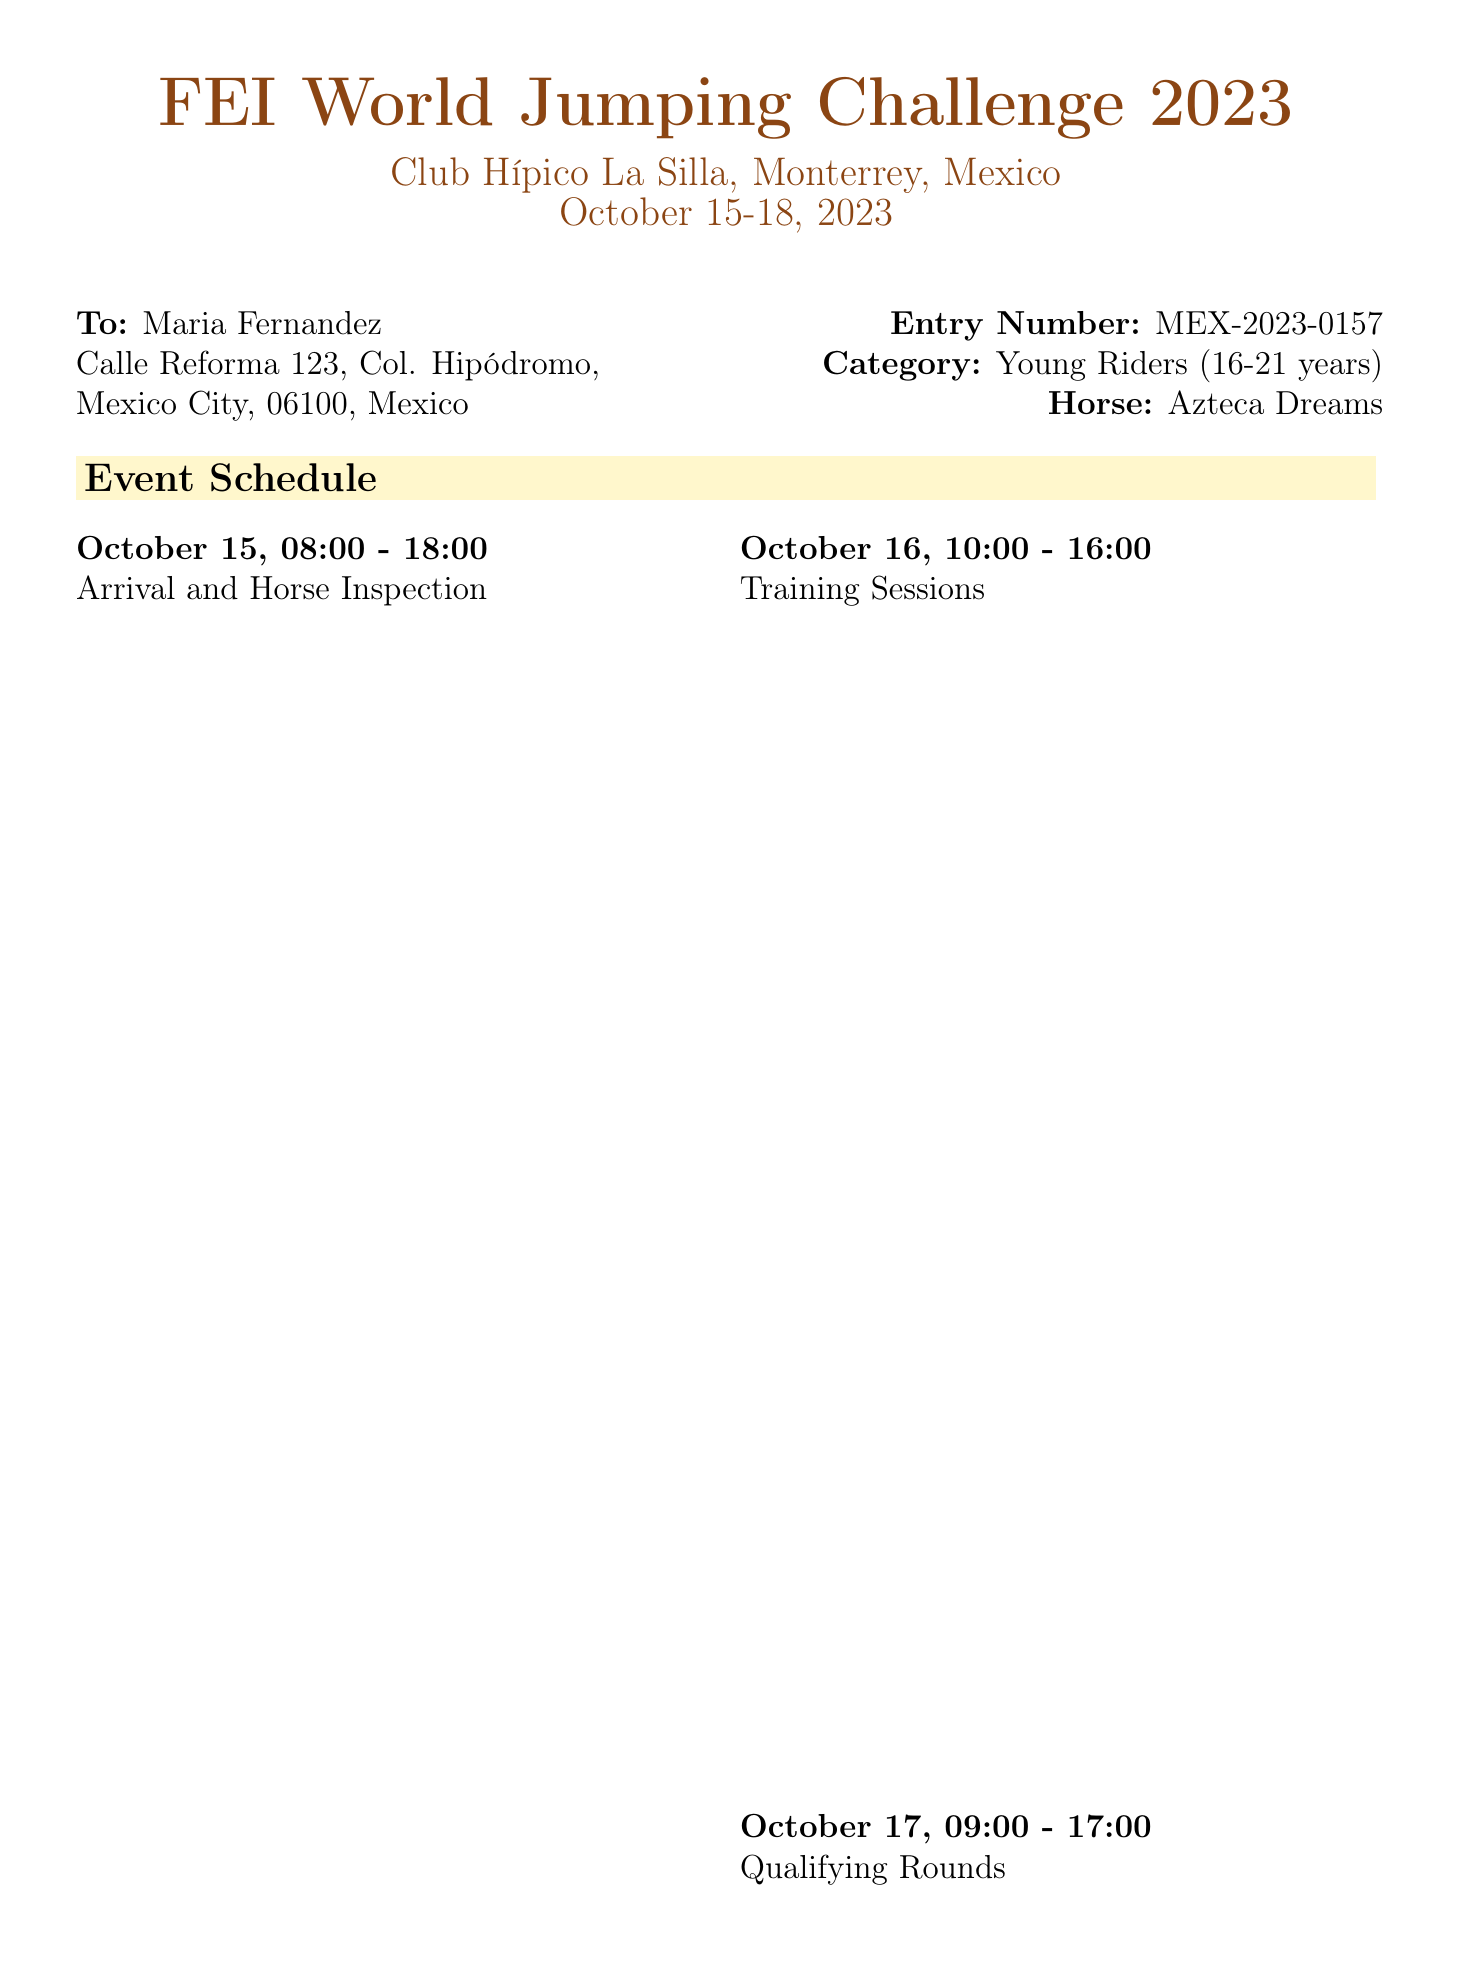What is the event name? The document clearly states the event name at the top.
Answer: FEI World Jumping Challenge 2023 What are the dates of the competition? The competition dates are mentioned right below the event name.
Answer: October 15-18, 2023 Who is the contact person for the event? The contact person is listed in the additional information section.
Answer: Carlos Ramirez What is the stall number for stabling? The stall number is explicitly mentioned in the stabling information table.
Answer: 127 What is the check-in time for stabling? The check-in time is provided in the stabling information section.
Answer: October 15, 07:00 How many days does the event last? The duration can be calculated by counting the given dates in the document.
Answer: 4 days What category does Maria Fernandez compete in? The category is specified along with the entry number in the document.
Answer: Young Riders (16-21 years) What time does the final round start? The starting time for the final round can be found in the event schedule section.
Answer: 13:00 Is veterinary service available? The document states the availability of veterinary services in the additional information section.
Answer: Yes, 24/7 